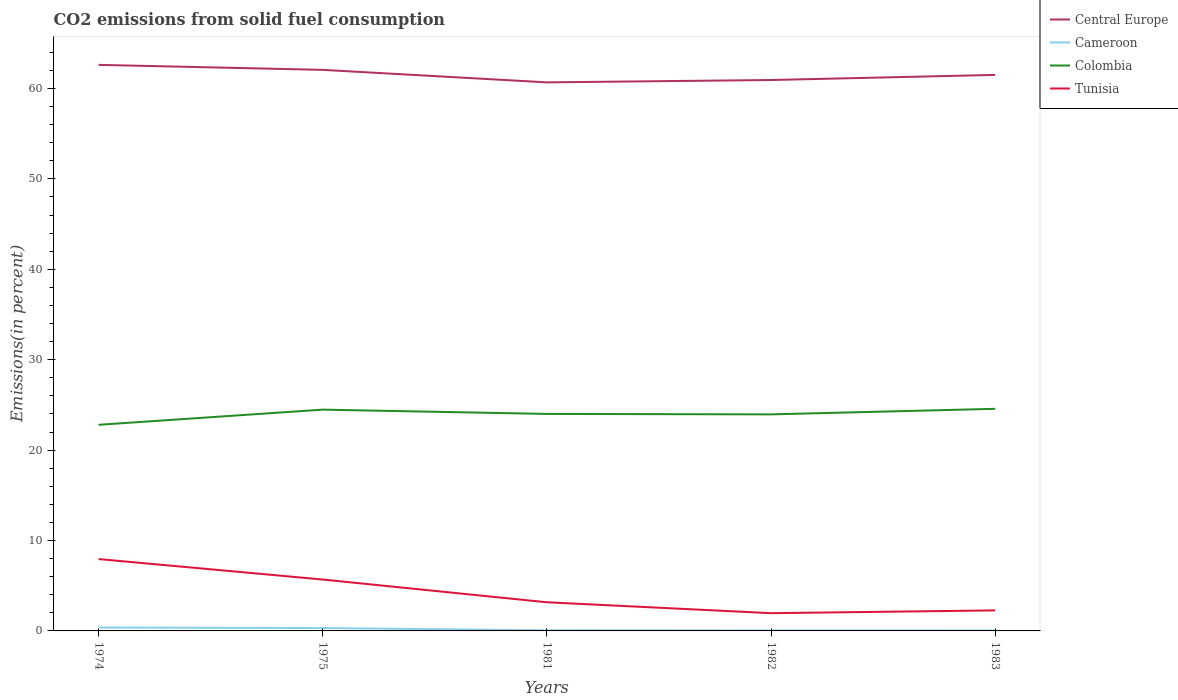How many different coloured lines are there?
Offer a terse response. 4. Does the line corresponding to Central Europe intersect with the line corresponding to Cameroon?
Offer a very short reply. No. Across all years, what is the maximum total CO2 emitted in Tunisia?
Your answer should be very brief. 1.96. What is the total total CO2 emitted in Central Europe in the graph?
Your answer should be very brief. 1.11. What is the difference between the highest and the second highest total CO2 emitted in Colombia?
Your response must be concise. 1.77. How many lines are there?
Your answer should be very brief. 4. How many years are there in the graph?
Your answer should be compact. 5. Does the graph contain any zero values?
Offer a very short reply. No. Where does the legend appear in the graph?
Your answer should be very brief. Top right. How many legend labels are there?
Provide a succinct answer. 4. What is the title of the graph?
Offer a terse response. CO2 emissions from solid fuel consumption. Does "Croatia" appear as one of the legend labels in the graph?
Offer a terse response. No. What is the label or title of the X-axis?
Give a very brief answer. Years. What is the label or title of the Y-axis?
Your response must be concise. Emissions(in percent). What is the Emissions(in percent) of Central Europe in 1974?
Your response must be concise. 62.61. What is the Emissions(in percent) of Cameroon in 1974?
Ensure brevity in your answer.  0.38. What is the Emissions(in percent) of Colombia in 1974?
Give a very brief answer. 22.8. What is the Emissions(in percent) in Tunisia in 1974?
Ensure brevity in your answer.  7.95. What is the Emissions(in percent) of Central Europe in 1975?
Give a very brief answer. 62.06. What is the Emissions(in percent) in Cameroon in 1975?
Your answer should be compact. 0.32. What is the Emissions(in percent) of Colombia in 1975?
Provide a short and direct response. 24.48. What is the Emissions(in percent) of Tunisia in 1975?
Your response must be concise. 5.68. What is the Emissions(in percent) in Central Europe in 1981?
Your answer should be compact. 60.68. What is the Emissions(in percent) in Cameroon in 1981?
Your answer should be very brief. 0.07. What is the Emissions(in percent) in Colombia in 1981?
Your answer should be very brief. 24. What is the Emissions(in percent) of Tunisia in 1981?
Offer a terse response. 3.17. What is the Emissions(in percent) in Central Europe in 1982?
Offer a terse response. 60.93. What is the Emissions(in percent) of Cameroon in 1982?
Offer a terse response. 0.06. What is the Emissions(in percent) in Colombia in 1982?
Your response must be concise. 23.95. What is the Emissions(in percent) in Tunisia in 1982?
Your answer should be very brief. 1.96. What is the Emissions(in percent) of Central Europe in 1983?
Make the answer very short. 61.5. What is the Emissions(in percent) in Cameroon in 1983?
Ensure brevity in your answer.  0.06. What is the Emissions(in percent) of Colombia in 1983?
Your response must be concise. 24.57. What is the Emissions(in percent) in Tunisia in 1983?
Offer a terse response. 2.27. Across all years, what is the maximum Emissions(in percent) of Central Europe?
Your answer should be compact. 62.61. Across all years, what is the maximum Emissions(in percent) of Cameroon?
Ensure brevity in your answer.  0.38. Across all years, what is the maximum Emissions(in percent) of Colombia?
Your answer should be compact. 24.57. Across all years, what is the maximum Emissions(in percent) of Tunisia?
Offer a very short reply. 7.95. Across all years, what is the minimum Emissions(in percent) in Central Europe?
Your response must be concise. 60.68. Across all years, what is the minimum Emissions(in percent) of Cameroon?
Give a very brief answer. 0.06. Across all years, what is the minimum Emissions(in percent) of Colombia?
Offer a terse response. 22.8. Across all years, what is the minimum Emissions(in percent) in Tunisia?
Make the answer very short. 1.96. What is the total Emissions(in percent) in Central Europe in the graph?
Provide a succinct answer. 307.78. What is the total Emissions(in percent) in Cameroon in the graph?
Offer a terse response. 0.87. What is the total Emissions(in percent) of Colombia in the graph?
Your answer should be very brief. 119.8. What is the total Emissions(in percent) of Tunisia in the graph?
Offer a terse response. 21.04. What is the difference between the Emissions(in percent) in Central Europe in 1974 and that in 1975?
Give a very brief answer. 0.55. What is the difference between the Emissions(in percent) of Cameroon in 1974 and that in 1975?
Your answer should be compact. 0.06. What is the difference between the Emissions(in percent) in Colombia in 1974 and that in 1975?
Keep it short and to the point. -1.68. What is the difference between the Emissions(in percent) in Tunisia in 1974 and that in 1975?
Ensure brevity in your answer.  2.26. What is the difference between the Emissions(in percent) of Central Europe in 1974 and that in 1981?
Ensure brevity in your answer.  1.94. What is the difference between the Emissions(in percent) in Cameroon in 1974 and that in 1981?
Ensure brevity in your answer.  0.31. What is the difference between the Emissions(in percent) in Colombia in 1974 and that in 1981?
Your answer should be very brief. -1.2. What is the difference between the Emissions(in percent) in Tunisia in 1974 and that in 1981?
Your response must be concise. 4.78. What is the difference between the Emissions(in percent) in Central Europe in 1974 and that in 1982?
Your answer should be compact. 1.68. What is the difference between the Emissions(in percent) in Cameroon in 1974 and that in 1982?
Offer a terse response. 0.32. What is the difference between the Emissions(in percent) in Colombia in 1974 and that in 1982?
Your answer should be very brief. -1.15. What is the difference between the Emissions(in percent) of Tunisia in 1974 and that in 1982?
Make the answer very short. 5.99. What is the difference between the Emissions(in percent) of Central Europe in 1974 and that in 1983?
Ensure brevity in your answer.  1.11. What is the difference between the Emissions(in percent) in Cameroon in 1974 and that in 1983?
Offer a terse response. 0.32. What is the difference between the Emissions(in percent) of Colombia in 1974 and that in 1983?
Your answer should be compact. -1.77. What is the difference between the Emissions(in percent) of Tunisia in 1974 and that in 1983?
Provide a short and direct response. 5.68. What is the difference between the Emissions(in percent) in Central Europe in 1975 and that in 1981?
Provide a succinct answer. 1.38. What is the difference between the Emissions(in percent) of Cameroon in 1975 and that in 1981?
Provide a short and direct response. 0.25. What is the difference between the Emissions(in percent) in Colombia in 1975 and that in 1981?
Your response must be concise. 0.47. What is the difference between the Emissions(in percent) of Tunisia in 1975 and that in 1981?
Provide a short and direct response. 2.51. What is the difference between the Emissions(in percent) of Central Europe in 1975 and that in 1982?
Your answer should be very brief. 1.12. What is the difference between the Emissions(in percent) in Cameroon in 1975 and that in 1982?
Offer a very short reply. 0.26. What is the difference between the Emissions(in percent) in Colombia in 1975 and that in 1982?
Offer a terse response. 0.52. What is the difference between the Emissions(in percent) in Tunisia in 1975 and that in 1982?
Make the answer very short. 3.72. What is the difference between the Emissions(in percent) of Central Europe in 1975 and that in 1983?
Keep it short and to the point. 0.56. What is the difference between the Emissions(in percent) of Cameroon in 1975 and that in 1983?
Your response must be concise. 0.26. What is the difference between the Emissions(in percent) in Colombia in 1975 and that in 1983?
Your response must be concise. -0.09. What is the difference between the Emissions(in percent) in Tunisia in 1975 and that in 1983?
Keep it short and to the point. 3.41. What is the difference between the Emissions(in percent) in Central Europe in 1981 and that in 1982?
Offer a terse response. -0.26. What is the difference between the Emissions(in percent) of Cameroon in 1981 and that in 1982?
Your response must be concise. 0.01. What is the difference between the Emissions(in percent) in Colombia in 1981 and that in 1982?
Your answer should be compact. 0.05. What is the difference between the Emissions(in percent) in Tunisia in 1981 and that in 1982?
Ensure brevity in your answer.  1.21. What is the difference between the Emissions(in percent) of Central Europe in 1981 and that in 1983?
Give a very brief answer. -0.82. What is the difference between the Emissions(in percent) in Cameroon in 1981 and that in 1983?
Ensure brevity in your answer.  0.01. What is the difference between the Emissions(in percent) of Colombia in 1981 and that in 1983?
Provide a succinct answer. -0.57. What is the difference between the Emissions(in percent) of Tunisia in 1981 and that in 1983?
Ensure brevity in your answer.  0.9. What is the difference between the Emissions(in percent) in Central Europe in 1982 and that in 1983?
Your answer should be compact. -0.57. What is the difference between the Emissions(in percent) of Cameroon in 1982 and that in 1983?
Keep it short and to the point. 0. What is the difference between the Emissions(in percent) of Colombia in 1982 and that in 1983?
Keep it short and to the point. -0.62. What is the difference between the Emissions(in percent) in Tunisia in 1982 and that in 1983?
Your answer should be very brief. -0.31. What is the difference between the Emissions(in percent) in Central Europe in 1974 and the Emissions(in percent) in Cameroon in 1975?
Your response must be concise. 62.3. What is the difference between the Emissions(in percent) of Central Europe in 1974 and the Emissions(in percent) of Colombia in 1975?
Give a very brief answer. 38.14. What is the difference between the Emissions(in percent) of Central Europe in 1974 and the Emissions(in percent) of Tunisia in 1975?
Ensure brevity in your answer.  56.93. What is the difference between the Emissions(in percent) in Cameroon in 1974 and the Emissions(in percent) in Colombia in 1975?
Provide a short and direct response. -24.1. What is the difference between the Emissions(in percent) of Cameroon in 1974 and the Emissions(in percent) of Tunisia in 1975?
Offer a very short reply. -5.31. What is the difference between the Emissions(in percent) of Colombia in 1974 and the Emissions(in percent) of Tunisia in 1975?
Provide a succinct answer. 17.11. What is the difference between the Emissions(in percent) in Central Europe in 1974 and the Emissions(in percent) in Cameroon in 1981?
Your answer should be very brief. 62.54. What is the difference between the Emissions(in percent) in Central Europe in 1974 and the Emissions(in percent) in Colombia in 1981?
Provide a succinct answer. 38.61. What is the difference between the Emissions(in percent) of Central Europe in 1974 and the Emissions(in percent) of Tunisia in 1981?
Offer a very short reply. 59.44. What is the difference between the Emissions(in percent) of Cameroon in 1974 and the Emissions(in percent) of Colombia in 1981?
Provide a succinct answer. -23.63. What is the difference between the Emissions(in percent) of Cameroon in 1974 and the Emissions(in percent) of Tunisia in 1981?
Offer a very short reply. -2.79. What is the difference between the Emissions(in percent) in Colombia in 1974 and the Emissions(in percent) in Tunisia in 1981?
Give a very brief answer. 19.63. What is the difference between the Emissions(in percent) of Central Europe in 1974 and the Emissions(in percent) of Cameroon in 1982?
Offer a terse response. 62.55. What is the difference between the Emissions(in percent) of Central Europe in 1974 and the Emissions(in percent) of Colombia in 1982?
Make the answer very short. 38.66. What is the difference between the Emissions(in percent) of Central Europe in 1974 and the Emissions(in percent) of Tunisia in 1982?
Give a very brief answer. 60.65. What is the difference between the Emissions(in percent) of Cameroon in 1974 and the Emissions(in percent) of Colombia in 1982?
Your answer should be very brief. -23.58. What is the difference between the Emissions(in percent) in Cameroon in 1974 and the Emissions(in percent) in Tunisia in 1982?
Your answer should be compact. -1.59. What is the difference between the Emissions(in percent) of Colombia in 1974 and the Emissions(in percent) of Tunisia in 1982?
Ensure brevity in your answer.  20.84. What is the difference between the Emissions(in percent) of Central Europe in 1974 and the Emissions(in percent) of Cameroon in 1983?
Offer a very short reply. 62.56. What is the difference between the Emissions(in percent) in Central Europe in 1974 and the Emissions(in percent) in Colombia in 1983?
Your answer should be compact. 38.04. What is the difference between the Emissions(in percent) in Central Europe in 1974 and the Emissions(in percent) in Tunisia in 1983?
Offer a terse response. 60.34. What is the difference between the Emissions(in percent) of Cameroon in 1974 and the Emissions(in percent) of Colombia in 1983?
Give a very brief answer. -24.19. What is the difference between the Emissions(in percent) of Cameroon in 1974 and the Emissions(in percent) of Tunisia in 1983?
Provide a short and direct response. -1.89. What is the difference between the Emissions(in percent) in Colombia in 1974 and the Emissions(in percent) in Tunisia in 1983?
Provide a short and direct response. 20.53. What is the difference between the Emissions(in percent) in Central Europe in 1975 and the Emissions(in percent) in Cameroon in 1981?
Give a very brief answer. 61.99. What is the difference between the Emissions(in percent) in Central Europe in 1975 and the Emissions(in percent) in Colombia in 1981?
Ensure brevity in your answer.  38.06. What is the difference between the Emissions(in percent) in Central Europe in 1975 and the Emissions(in percent) in Tunisia in 1981?
Your response must be concise. 58.89. What is the difference between the Emissions(in percent) of Cameroon in 1975 and the Emissions(in percent) of Colombia in 1981?
Provide a short and direct response. -23.69. What is the difference between the Emissions(in percent) of Cameroon in 1975 and the Emissions(in percent) of Tunisia in 1981?
Give a very brief answer. -2.85. What is the difference between the Emissions(in percent) in Colombia in 1975 and the Emissions(in percent) in Tunisia in 1981?
Give a very brief answer. 21.31. What is the difference between the Emissions(in percent) in Central Europe in 1975 and the Emissions(in percent) in Cameroon in 1982?
Your answer should be compact. 62. What is the difference between the Emissions(in percent) of Central Europe in 1975 and the Emissions(in percent) of Colombia in 1982?
Provide a short and direct response. 38.11. What is the difference between the Emissions(in percent) in Central Europe in 1975 and the Emissions(in percent) in Tunisia in 1982?
Provide a short and direct response. 60.1. What is the difference between the Emissions(in percent) in Cameroon in 1975 and the Emissions(in percent) in Colombia in 1982?
Ensure brevity in your answer.  -23.64. What is the difference between the Emissions(in percent) in Cameroon in 1975 and the Emissions(in percent) in Tunisia in 1982?
Keep it short and to the point. -1.65. What is the difference between the Emissions(in percent) of Colombia in 1975 and the Emissions(in percent) of Tunisia in 1982?
Your answer should be compact. 22.51. What is the difference between the Emissions(in percent) in Central Europe in 1975 and the Emissions(in percent) in Cameroon in 1983?
Your answer should be compact. 62. What is the difference between the Emissions(in percent) in Central Europe in 1975 and the Emissions(in percent) in Colombia in 1983?
Your response must be concise. 37.49. What is the difference between the Emissions(in percent) of Central Europe in 1975 and the Emissions(in percent) of Tunisia in 1983?
Your response must be concise. 59.79. What is the difference between the Emissions(in percent) in Cameroon in 1975 and the Emissions(in percent) in Colombia in 1983?
Ensure brevity in your answer.  -24.25. What is the difference between the Emissions(in percent) in Cameroon in 1975 and the Emissions(in percent) in Tunisia in 1983?
Keep it short and to the point. -1.96. What is the difference between the Emissions(in percent) of Colombia in 1975 and the Emissions(in percent) of Tunisia in 1983?
Your response must be concise. 22.21. What is the difference between the Emissions(in percent) in Central Europe in 1981 and the Emissions(in percent) in Cameroon in 1982?
Keep it short and to the point. 60.62. What is the difference between the Emissions(in percent) in Central Europe in 1981 and the Emissions(in percent) in Colombia in 1982?
Offer a very short reply. 36.72. What is the difference between the Emissions(in percent) in Central Europe in 1981 and the Emissions(in percent) in Tunisia in 1982?
Ensure brevity in your answer.  58.71. What is the difference between the Emissions(in percent) in Cameroon in 1981 and the Emissions(in percent) in Colombia in 1982?
Your response must be concise. -23.88. What is the difference between the Emissions(in percent) of Cameroon in 1981 and the Emissions(in percent) of Tunisia in 1982?
Your answer should be very brief. -1.89. What is the difference between the Emissions(in percent) in Colombia in 1981 and the Emissions(in percent) in Tunisia in 1982?
Ensure brevity in your answer.  22.04. What is the difference between the Emissions(in percent) in Central Europe in 1981 and the Emissions(in percent) in Cameroon in 1983?
Provide a succinct answer. 60.62. What is the difference between the Emissions(in percent) of Central Europe in 1981 and the Emissions(in percent) of Colombia in 1983?
Offer a terse response. 36.11. What is the difference between the Emissions(in percent) of Central Europe in 1981 and the Emissions(in percent) of Tunisia in 1983?
Your answer should be very brief. 58.41. What is the difference between the Emissions(in percent) of Cameroon in 1981 and the Emissions(in percent) of Colombia in 1983?
Give a very brief answer. -24.5. What is the difference between the Emissions(in percent) of Cameroon in 1981 and the Emissions(in percent) of Tunisia in 1983?
Provide a succinct answer. -2.2. What is the difference between the Emissions(in percent) of Colombia in 1981 and the Emissions(in percent) of Tunisia in 1983?
Offer a very short reply. 21.73. What is the difference between the Emissions(in percent) of Central Europe in 1982 and the Emissions(in percent) of Cameroon in 1983?
Offer a terse response. 60.88. What is the difference between the Emissions(in percent) of Central Europe in 1982 and the Emissions(in percent) of Colombia in 1983?
Provide a succinct answer. 36.37. What is the difference between the Emissions(in percent) in Central Europe in 1982 and the Emissions(in percent) in Tunisia in 1983?
Keep it short and to the point. 58.66. What is the difference between the Emissions(in percent) in Cameroon in 1982 and the Emissions(in percent) in Colombia in 1983?
Offer a very short reply. -24.51. What is the difference between the Emissions(in percent) in Cameroon in 1982 and the Emissions(in percent) in Tunisia in 1983?
Offer a terse response. -2.21. What is the difference between the Emissions(in percent) of Colombia in 1982 and the Emissions(in percent) of Tunisia in 1983?
Provide a short and direct response. 21.68. What is the average Emissions(in percent) of Central Europe per year?
Keep it short and to the point. 61.56. What is the average Emissions(in percent) of Cameroon per year?
Your answer should be compact. 0.17. What is the average Emissions(in percent) in Colombia per year?
Provide a short and direct response. 23.96. What is the average Emissions(in percent) of Tunisia per year?
Provide a short and direct response. 4.21. In the year 1974, what is the difference between the Emissions(in percent) of Central Europe and Emissions(in percent) of Cameroon?
Make the answer very short. 62.24. In the year 1974, what is the difference between the Emissions(in percent) in Central Europe and Emissions(in percent) in Colombia?
Give a very brief answer. 39.81. In the year 1974, what is the difference between the Emissions(in percent) in Central Europe and Emissions(in percent) in Tunisia?
Provide a short and direct response. 54.66. In the year 1974, what is the difference between the Emissions(in percent) in Cameroon and Emissions(in percent) in Colombia?
Keep it short and to the point. -22.42. In the year 1974, what is the difference between the Emissions(in percent) in Cameroon and Emissions(in percent) in Tunisia?
Offer a very short reply. -7.57. In the year 1974, what is the difference between the Emissions(in percent) in Colombia and Emissions(in percent) in Tunisia?
Keep it short and to the point. 14.85. In the year 1975, what is the difference between the Emissions(in percent) in Central Europe and Emissions(in percent) in Cameroon?
Provide a succinct answer. 61.74. In the year 1975, what is the difference between the Emissions(in percent) in Central Europe and Emissions(in percent) in Colombia?
Offer a terse response. 37.58. In the year 1975, what is the difference between the Emissions(in percent) in Central Europe and Emissions(in percent) in Tunisia?
Offer a very short reply. 56.38. In the year 1975, what is the difference between the Emissions(in percent) of Cameroon and Emissions(in percent) of Colombia?
Offer a terse response. -24.16. In the year 1975, what is the difference between the Emissions(in percent) of Cameroon and Emissions(in percent) of Tunisia?
Provide a short and direct response. -5.37. In the year 1975, what is the difference between the Emissions(in percent) of Colombia and Emissions(in percent) of Tunisia?
Offer a terse response. 18.79. In the year 1981, what is the difference between the Emissions(in percent) of Central Europe and Emissions(in percent) of Cameroon?
Your answer should be very brief. 60.61. In the year 1981, what is the difference between the Emissions(in percent) in Central Europe and Emissions(in percent) in Colombia?
Provide a succinct answer. 36.67. In the year 1981, what is the difference between the Emissions(in percent) in Central Europe and Emissions(in percent) in Tunisia?
Your answer should be very brief. 57.51. In the year 1981, what is the difference between the Emissions(in percent) of Cameroon and Emissions(in percent) of Colombia?
Offer a terse response. -23.93. In the year 1981, what is the difference between the Emissions(in percent) of Cameroon and Emissions(in percent) of Tunisia?
Offer a terse response. -3.1. In the year 1981, what is the difference between the Emissions(in percent) of Colombia and Emissions(in percent) of Tunisia?
Your answer should be compact. 20.83. In the year 1982, what is the difference between the Emissions(in percent) in Central Europe and Emissions(in percent) in Cameroon?
Your answer should be very brief. 60.88. In the year 1982, what is the difference between the Emissions(in percent) of Central Europe and Emissions(in percent) of Colombia?
Your response must be concise. 36.98. In the year 1982, what is the difference between the Emissions(in percent) of Central Europe and Emissions(in percent) of Tunisia?
Provide a short and direct response. 58.97. In the year 1982, what is the difference between the Emissions(in percent) of Cameroon and Emissions(in percent) of Colombia?
Your answer should be very brief. -23.89. In the year 1982, what is the difference between the Emissions(in percent) of Cameroon and Emissions(in percent) of Tunisia?
Offer a very short reply. -1.91. In the year 1982, what is the difference between the Emissions(in percent) in Colombia and Emissions(in percent) in Tunisia?
Make the answer very short. 21.99. In the year 1983, what is the difference between the Emissions(in percent) of Central Europe and Emissions(in percent) of Cameroon?
Ensure brevity in your answer.  61.44. In the year 1983, what is the difference between the Emissions(in percent) of Central Europe and Emissions(in percent) of Colombia?
Make the answer very short. 36.93. In the year 1983, what is the difference between the Emissions(in percent) of Central Europe and Emissions(in percent) of Tunisia?
Make the answer very short. 59.23. In the year 1983, what is the difference between the Emissions(in percent) in Cameroon and Emissions(in percent) in Colombia?
Offer a very short reply. -24.51. In the year 1983, what is the difference between the Emissions(in percent) in Cameroon and Emissions(in percent) in Tunisia?
Your response must be concise. -2.21. In the year 1983, what is the difference between the Emissions(in percent) of Colombia and Emissions(in percent) of Tunisia?
Offer a terse response. 22.3. What is the ratio of the Emissions(in percent) of Central Europe in 1974 to that in 1975?
Give a very brief answer. 1.01. What is the ratio of the Emissions(in percent) of Cameroon in 1974 to that in 1975?
Offer a very short reply. 1.19. What is the ratio of the Emissions(in percent) in Colombia in 1974 to that in 1975?
Your response must be concise. 0.93. What is the ratio of the Emissions(in percent) of Tunisia in 1974 to that in 1975?
Offer a terse response. 1.4. What is the ratio of the Emissions(in percent) in Central Europe in 1974 to that in 1981?
Offer a very short reply. 1.03. What is the ratio of the Emissions(in percent) of Cameroon in 1974 to that in 1981?
Your answer should be compact. 5.48. What is the ratio of the Emissions(in percent) in Colombia in 1974 to that in 1981?
Provide a succinct answer. 0.95. What is the ratio of the Emissions(in percent) in Tunisia in 1974 to that in 1981?
Keep it short and to the point. 2.51. What is the ratio of the Emissions(in percent) of Central Europe in 1974 to that in 1982?
Make the answer very short. 1.03. What is the ratio of the Emissions(in percent) of Cameroon in 1974 to that in 1982?
Keep it short and to the point. 6.5. What is the ratio of the Emissions(in percent) of Colombia in 1974 to that in 1982?
Offer a terse response. 0.95. What is the ratio of the Emissions(in percent) of Tunisia in 1974 to that in 1982?
Your answer should be compact. 4.05. What is the ratio of the Emissions(in percent) of Central Europe in 1974 to that in 1983?
Offer a terse response. 1.02. What is the ratio of the Emissions(in percent) in Cameroon in 1974 to that in 1983?
Your answer should be very brief. 6.76. What is the ratio of the Emissions(in percent) in Colombia in 1974 to that in 1983?
Offer a very short reply. 0.93. What is the ratio of the Emissions(in percent) of Tunisia in 1974 to that in 1983?
Provide a succinct answer. 3.5. What is the ratio of the Emissions(in percent) of Central Europe in 1975 to that in 1981?
Your answer should be very brief. 1.02. What is the ratio of the Emissions(in percent) of Cameroon in 1975 to that in 1981?
Provide a short and direct response. 4.6. What is the ratio of the Emissions(in percent) of Colombia in 1975 to that in 1981?
Give a very brief answer. 1.02. What is the ratio of the Emissions(in percent) in Tunisia in 1975 to that in 1981?
Your answer should be very brief. 1.79. What is the ratio of the Emissions(in percent) of Central Europe in 1975 to that in 1982?
Give a very brief answer. 1.02. What is the ratio of the Emissions(in percent) in Cameroon in 1975 to that in 1982?
Ensure brevity in your answer.  5.46. What is the ratio of the Emissions(in percent) of Colombia in 1975 to that in 1982?
Ensure brevity in your answer.  1.02. What is the ratio of the Emissions(in percent) in Tunisia in 1975 to that in 1982?
Offer a terse response. 2.9. What is the ratio of the Emissions(in percent) of Central Europe in 1975 to that in 1983?
Make the answer very short. 1.01. What is the ratio of the Emissions(in percent) in Cameroon in 1975 to that in 1983?
Make the answer very short. 5.67. What is the ratio of the Emissions(in percent) of Colombia in 1975 to that in 1983?
Make the answer very short. 1. What is the ratio of the Emissions(in percent) of Tunisia in 1975 to that in 1983?
Provide a short and direct response. 2.5. What is the ratio of the Emissions(in percent) in Central Europe in 1981 to that in 1982?
Give a very brief answer. 1. What is the ratio of the Emissions(in percent) in Cameroon in 1981 to that in 1982?
Keep it short and to the point. 1.19. What is the ratio of the Emissions(in percent) in Tunisia in 1981 to that in 1982?
Your answer should be very brief. 1.61. What is the ratio of the Emissions(in percent) in Central Europe in 1981 to that in 1983?
Offer a terse response. 0.99. What is the ratio of the Emissions(in percent) in Cameroon in 1981 to that in 1983?
Provide a succinct answer. 1.23. What is the ratio of the Emissions(in percent) of Colombia in 1981 to that in 1983?
Provide a succinct answer. 0.98. What is the ratio of the Emissions(in percent) in Tunisia in 1981 to that in 1983?
Ensure brevity in your answer.  1.4. What is the ratio of the Emissions(in percent) of Central Europe in 1982 to that in 1983?
Offer a terse response. 0.99. What is the ratio of the Emissions(in percent) in Cameroon in 1982 to that in 1983?
Make the answer very short. 1.04. What is the ratio of the Emissions(in percent) in Colombia in 1982 to that in 1983?
Your response must be concise. 0.97. What is the ratio of the Emissions(in percent) of Tunisia in 1982 to that in 1983?
Provide a succinct answer. 0.86. What is the difference between the highest and the second highest Emissions(in percent) in Central Europe?
Ensure brevity in your answer.  0.55. What is the difference between the highest and the second highest Emissions(in percent) in Cameroon?
Offer a very short reply. 0.06. What is the difference between the highest and the second highest Emissions(in percent) in Colombia?
Your response must be concise. 0.09. What is the difference between the highest and the second highest Emissions(in percent) of Tunisia?
Provide a short and direct response. 2.26. What is the difference between the highest and the lowest Emissions(in percent) in Central Europe?
Ensure brevity in your answer.  1.94. What is the difference between the highest and the lowest Emissions(in percent) in Cameroon?
Ensure brevity in your answer.  0.32. What is the difference between the highest and the lowest Emissions(in percent) in Colombia?
Make the answer very short. 1.77. What is the difference between the highest and the lowest Emissions(in percent) in Tunisia?
Offer a very short reply. 5.99. 